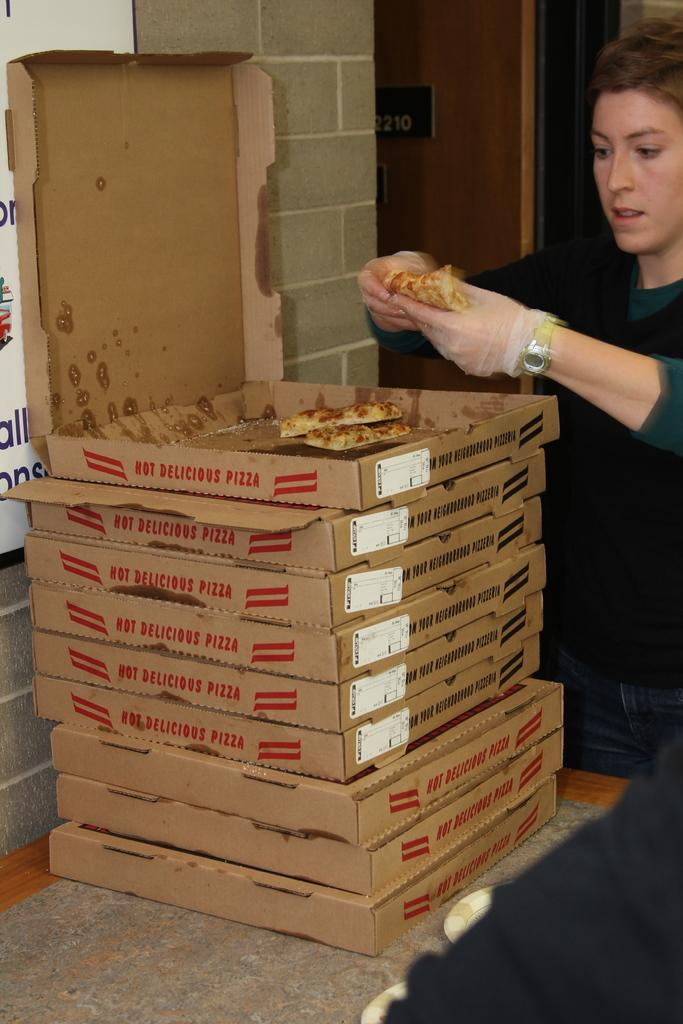<image>
Provide a brief description of the given image. A woman takes a slice from the stack of HOT DELICIOUS PIZZA. 